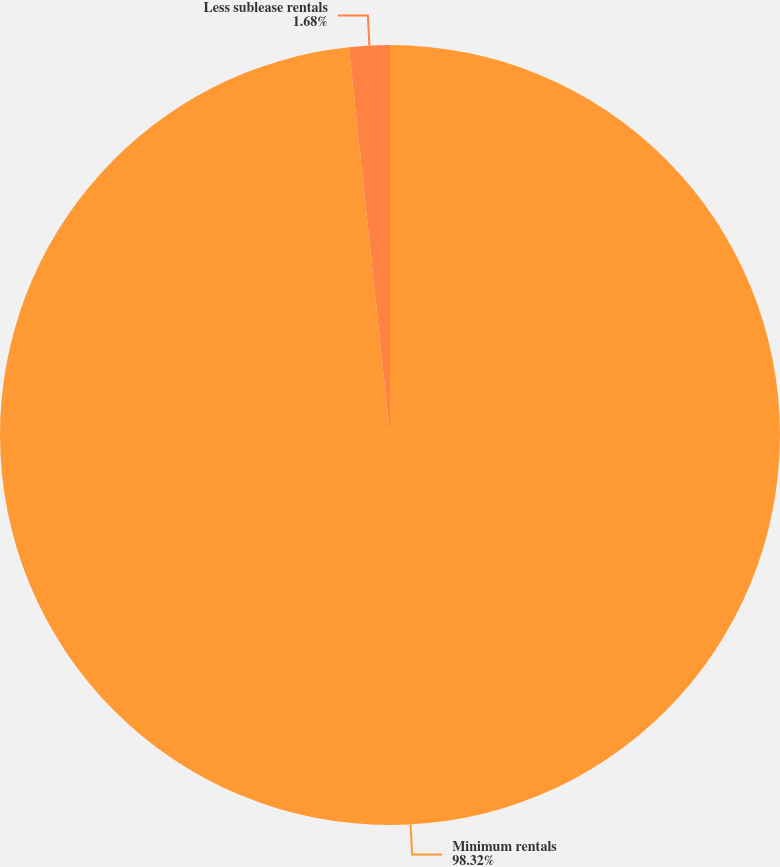Convert chart to OTSL. <chart><loc_0><loc_0><loc_500><loc_500><pie_chart><fcel>Minimum rentals<fcel>Less sublease rentals<nl><fcel>98.32%<fcel>1.68%<nl></chart> 